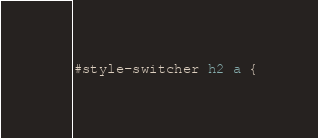<code> <loc_0><loc_0><loc_500><loc_500><_CSS_>#style-switcher h2 a {</code> 